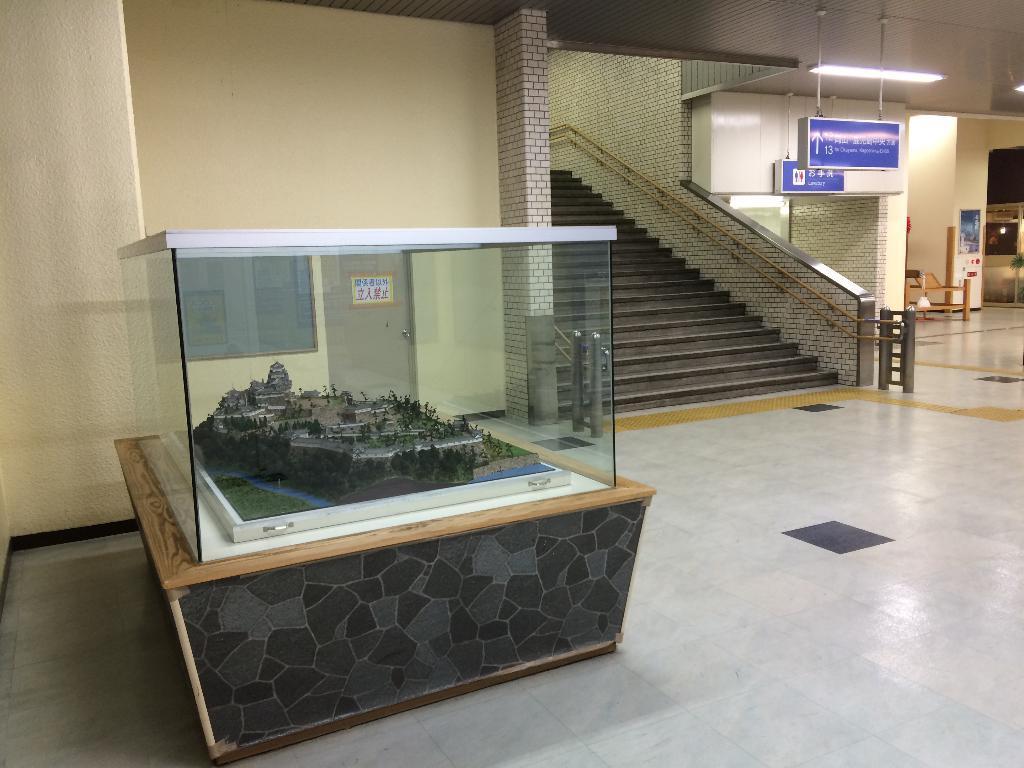Describe this image in one or two sentences. In this image I can see a table and on it I can see a glass box. I can also see a miniature set in the box. In the background I can see a door, number of boards, stairs, railings, two lights and on these boards I can see something is written. On the right side of this image I can see a plant and few other things. 